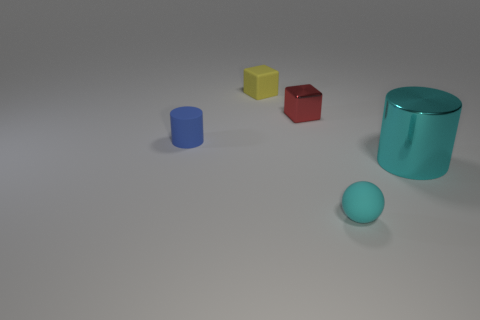Subtract all spheres. How many objects are left? 4 Add 3 blue shiny things. How many objects exist? 8 Subtract all brown balls. How many blue cubes are left? 0 Subtract all tiny cyan spheres. Subtract all tiny shiny objects. How many objects are left? 3 Add 1 small blue cylinders. How many small blue cylinders are left? 2 Add 3 large gray shiny blocks. How many large gray shiny blocks exist? 3 Subtract all blue cylinders. How many cylinders are left? 1 Subtract 0 green cylinders. How many objects are left? 5 Subtract all brown cylinders. Subtract all red balls. How many cylinders are left? 2 